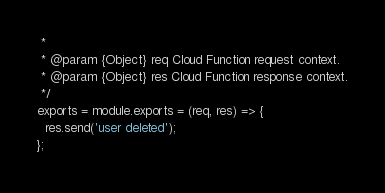<code> <loc_0><loc_0><loc_500><loc_500><_JavaScript_> *
 * @param {Object} req Cloud Function request context.
 * @param {Object} res Cloud Function response context.
 */
exports = module.exports = (req, res) => {
  res.send('user deleted');
};
</code> 